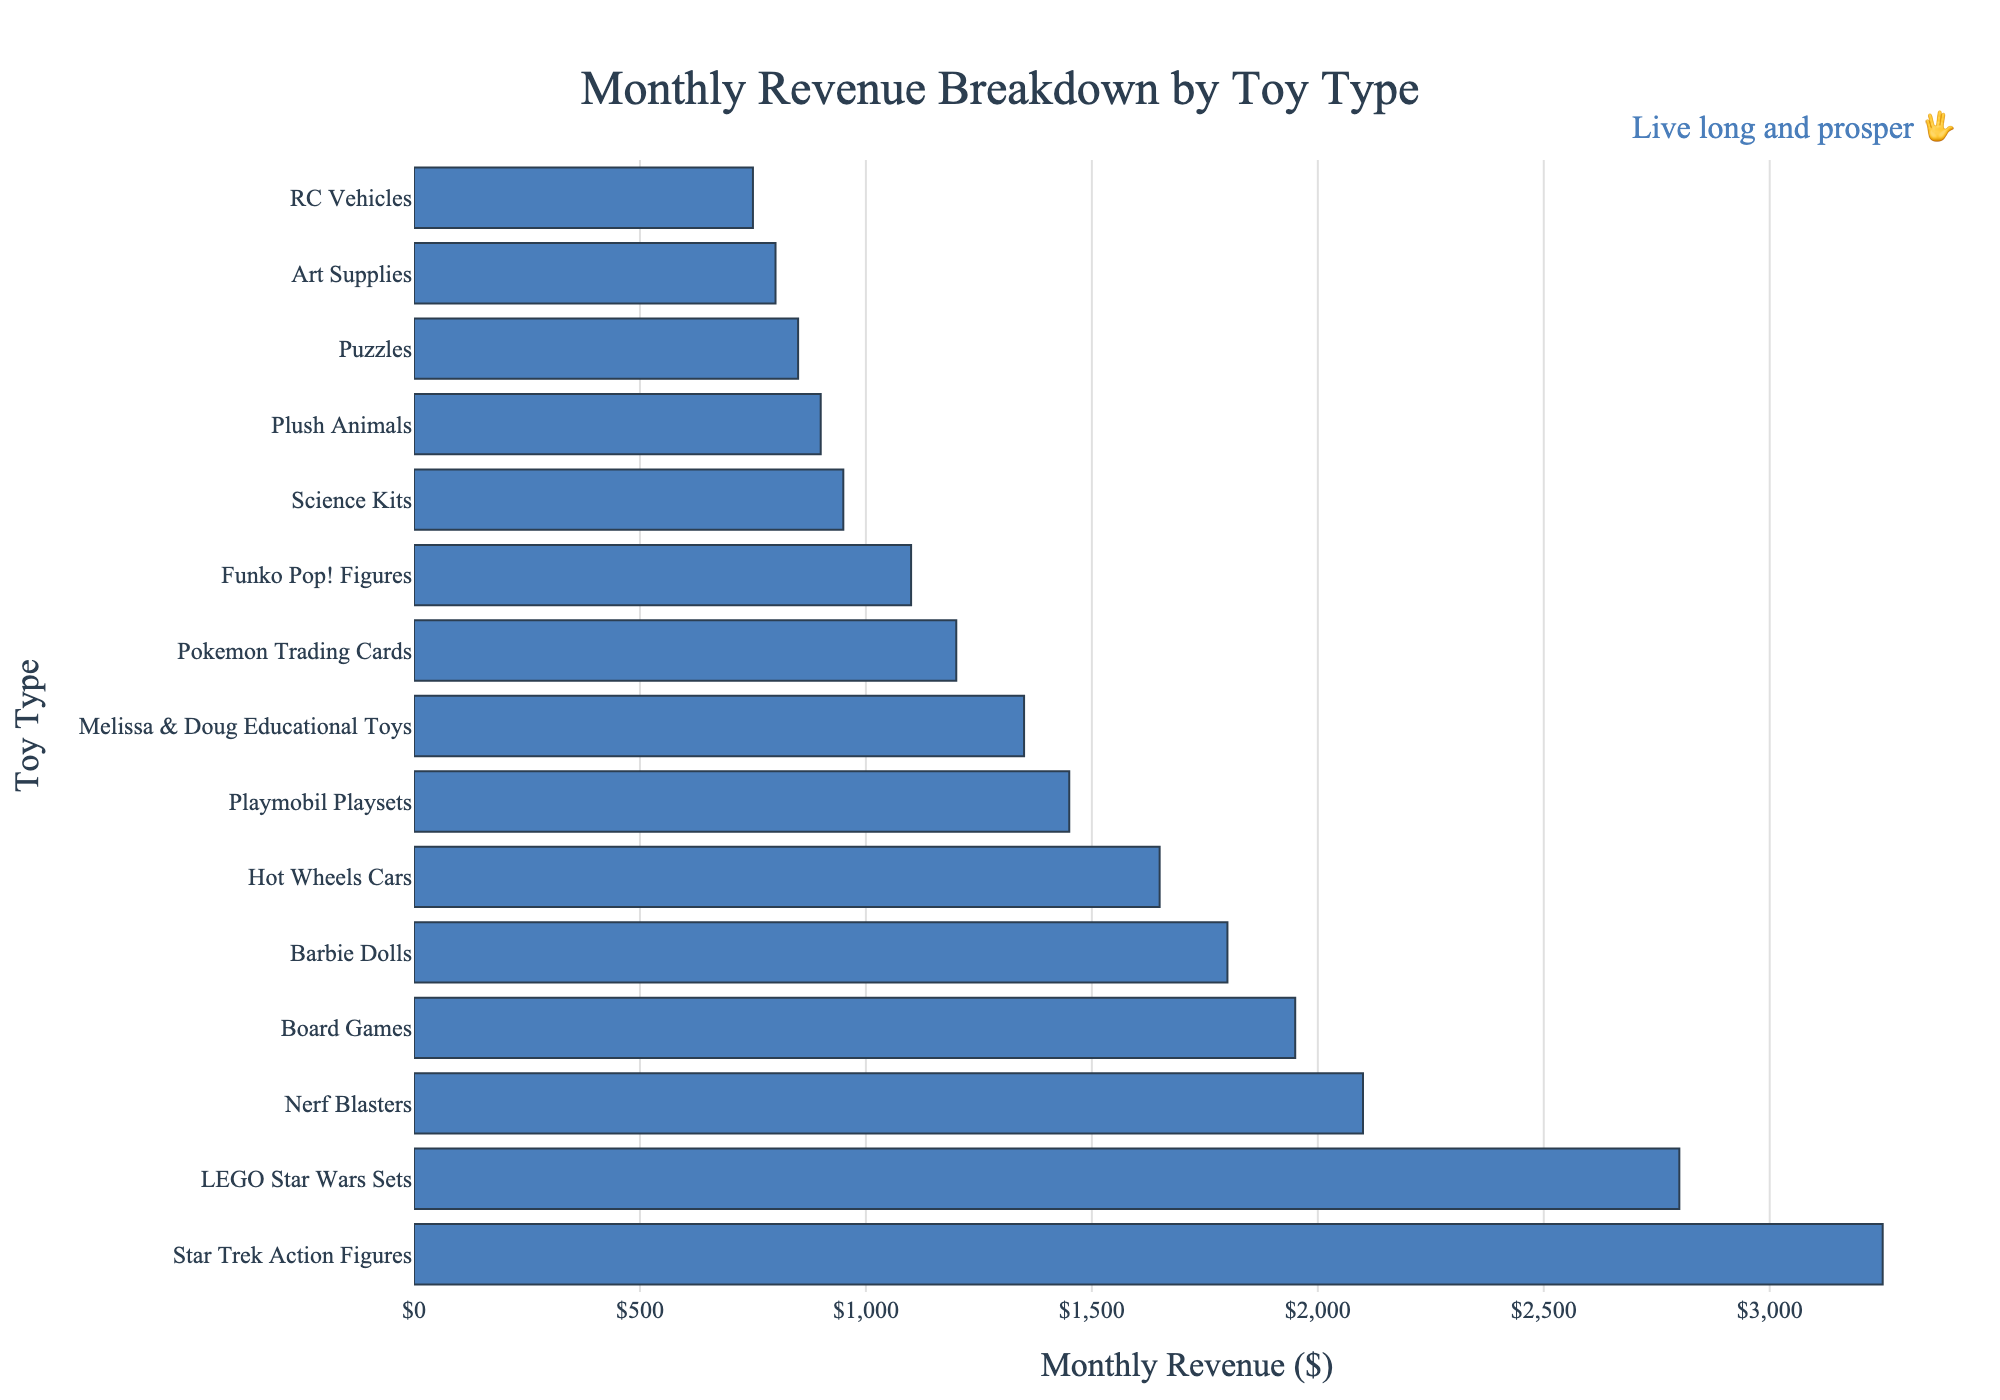What is the highest monthly revenue among the toy types? The highest monthly revenue can be found by identifying the tallest bar in the bar chart. The Star Trek Action Figures have the highest bar and a corresponding revenue value of $3250.
Answer: $3250 Which toy type has lower monthly revenue, Nerf Blasters or Board Games? By locating the bars for Nerf Blasters and Board Games on the chart and comparing their lengths, it is clear that Nerf Blasters have a revenue of $2100 and Board Games have $1950. Since $1950 is less than $2100, Board Games have lower revenue.
Answer: Board Games What is the total monthly revenue of the top two toy types? The top two toy types based on revenue are Star Trek Action Figures with $3250 and LEGO Star Wars Sets with $2800. Summing these values gives $3250 + $2800 = $6050.
Answer: $6050 Which toy type has the closest monthly revenue to $2000? By examining the figure, the closest monthly revenue to $2000 is either Nerf Blasters at $2100 or Board Games at $1950. Among these, $1950 (for Board Games) is closer to $2000 than $2100.
Answer: Board Games How much more revenue do Star Trek Action Figures generate compared to Barbie Dolls? Star Trek Action Figures generate $3250, while Barbie Dolls generate $1800. The difference in revenue is $3250 - $1800 = $1450.
Answer: $1450 Which toy type has the least monthly revenue, and what is that amount? The toy type with the least monthly revenue is represented by the shortest bar. Puzzles generate the least revenue, which is $850.
Answer: Puzzles, $850 What is the average monthly revenue of the top five toy types? The top five toy types are: Star Trek Action Figures ($3250), LEGO Star Wars Sets ($2800), Nerf Blasters ($2100), Board Games ($1950), and Barbie Dolls ($1800). Summing these gives $3250 + $2800 + $2100 + $1950 + $1800 = $11900. The average is $11900 / 5 = $2380.
Answer: $2380 Are there any two toy types that have the same monthly revenue? By inspecting the heights of the bars in the chart, none of the toy types have matching revenue values; all bars are of different lengths.
Answer: No What is the difference in monthly revenue between the highest and lowest revenue-generating toy types? The highest monthly revenue is $3250 (Star Trek Action Figures) and the lowest is $850 (Puzzles). The difference is $3250 - $850 = $2400.
Answer: $2400 